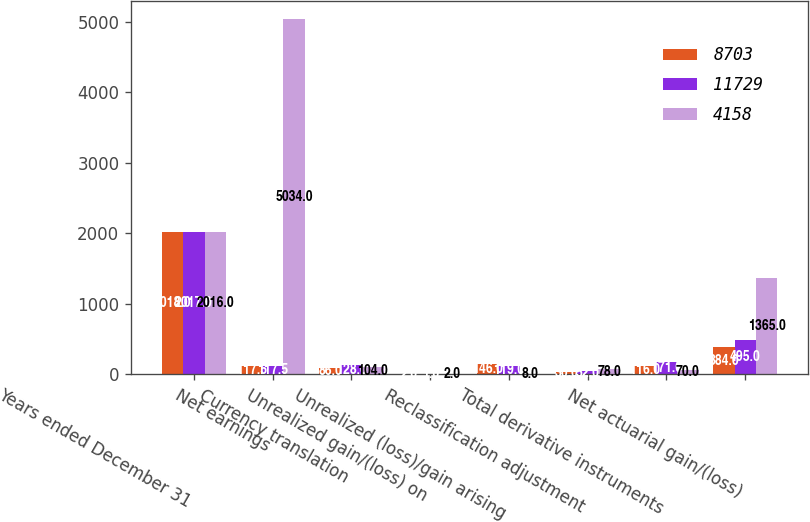Convert chart to OTSL. <chart><loc_0><loc_0><loc_500><loc_500><stacked_bar_chart><ecel><fcel>Years ended December 31<fcel>Net earnings<fcel>Currency translation<fcel>Unrealized gain/(loss) on<fcel>Unrealized (loss)/gain arising<fcel>Reclassification adjustment<fcel>Total derivative instruments<fcel>Net actuarial gain/(loss)<nl><fcel>8703<fcel>2018<fcel>117.5<fcel>86<fcel>2<fcel>146<fcel>30<fcel>116<fcel>384<nl><fcel>11729<fcel>2017<fcel>117.5<fcel>128<fcel>1<fcel>119<fcel>52<fcel>171<fcel>495<nl><fcel>4158<fcel>2016<fcel>5034<fcel>104<fcel>2<fcel>8<fcel>78<fcel>70<fcel>1365<nl></chart> 